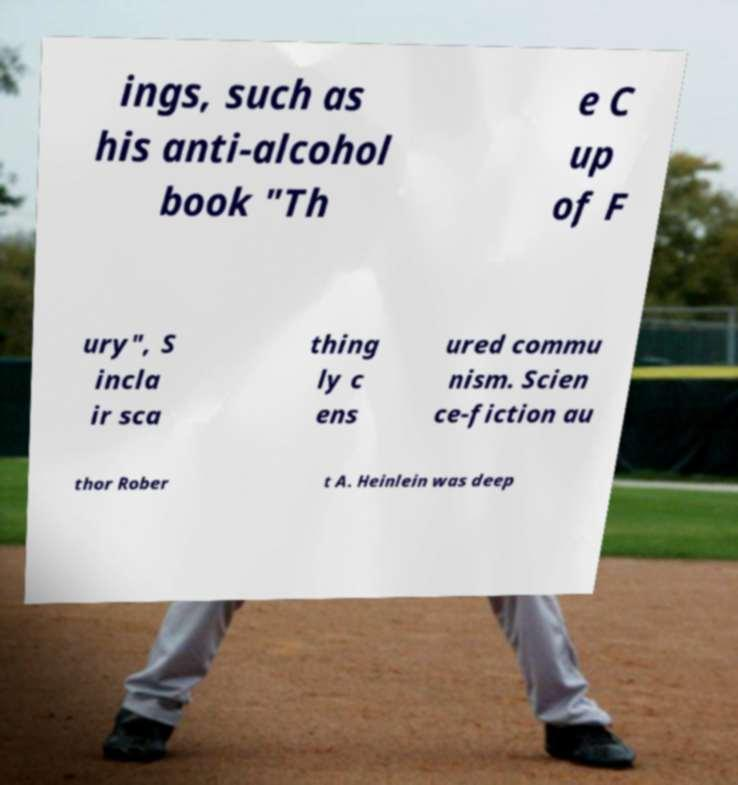Could you assist in decoding the text presented in this image and type it out clearly? ings, such as his anti-alcohol book "Th e C up of F ury", S incla ir sca thing ly c ens ured commu nism. Scien ce-fiction au thor Rober t A. Heinlein was deep 